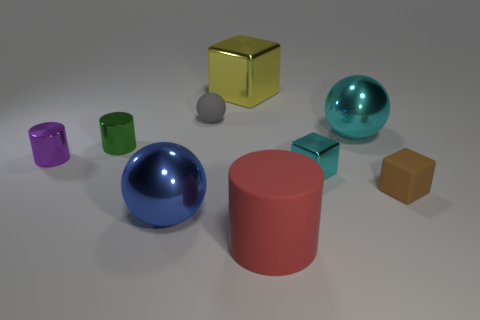Add 1 big red balls. How many objects exist? 10 Subtract all blocks. How many objects are left? 6 Subtract all metal things. Subtract all big blue shiny balls. How many objects are left? 2 Add 3 large blue things. How many large blue things are left? 4 Add 3 green cylinders. How many green cylinders exist? 4 Subtract 1 yellow blocks. How many objects are left? 8 